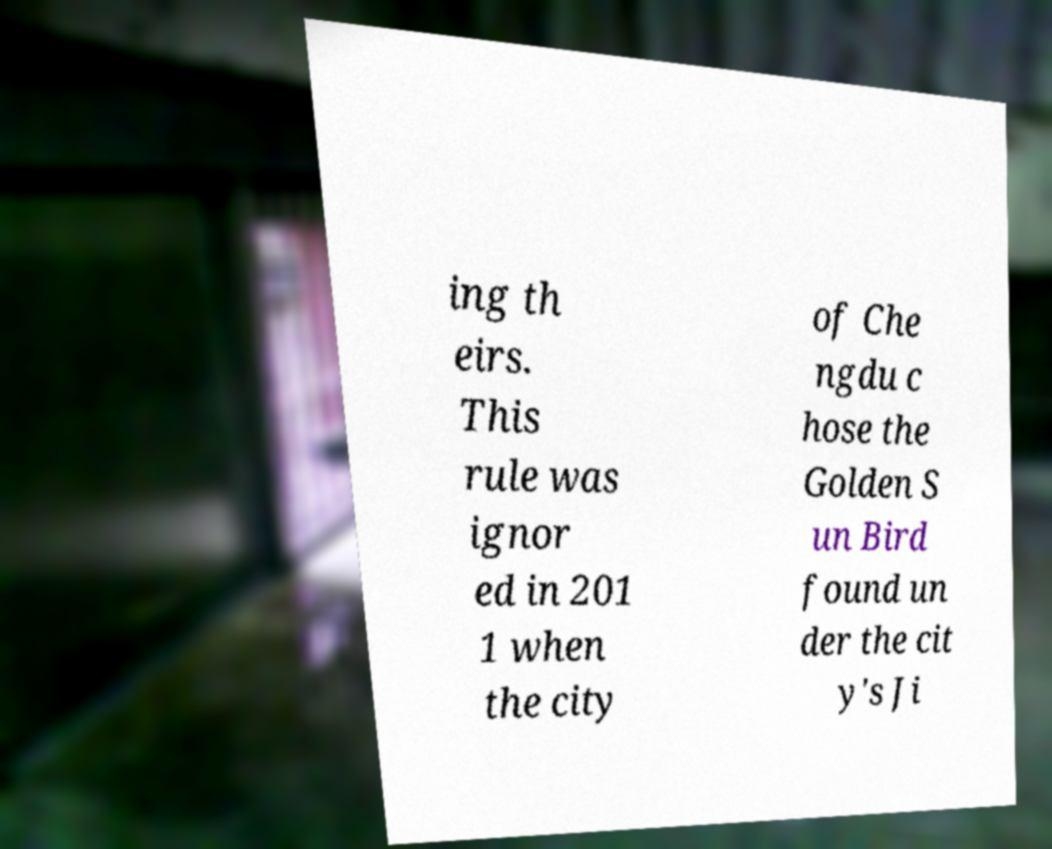What messages or text are displayed in this image? I need them in a readable, typed format. ing th eirs. This rule was ignor ed in 201 1 when the city of Che ngdu c hose the Golden S un Bird found un der the cit y's Ji 